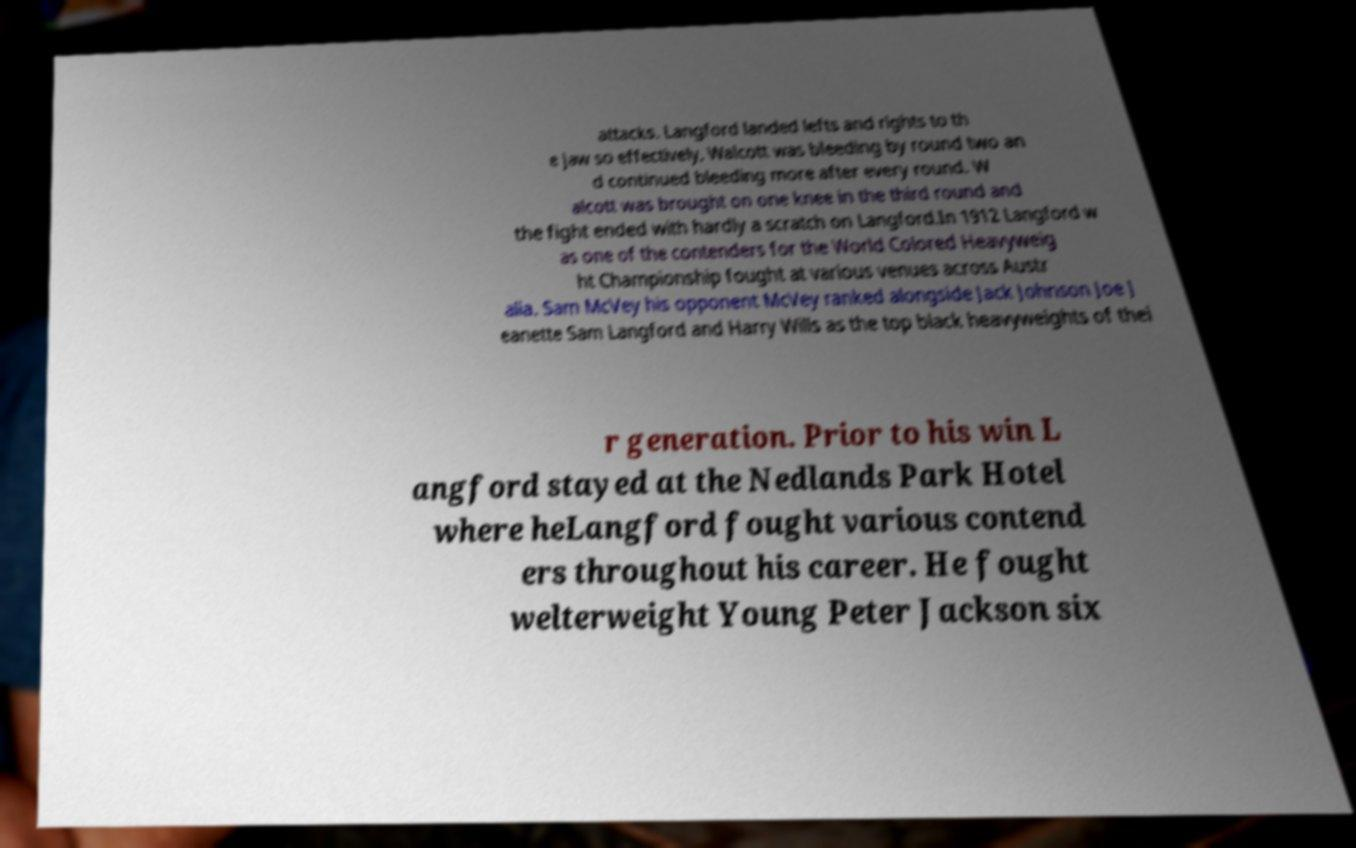Please identify and transcribe the text found in this image. attacks. Langford landed lefts and rights to th e jaw so effectively, Walcott was bleeding by round two an d continued bleeding more after every round. W alcott was brought on one knee in the third round and the fight ended with hardly a scratch on Langford.In 1912 Langford w as one of the contenders for the World Colored Heavyweig ht Championship fought at various venues across Austr alia. Sam McVey his opponent McVey ranked alongside Jack Johnson Joe J eanette Sam Langford and Harry Wills as the top black heavyweights of thei r generation. Prior to his win L angford stayed at the Nedlands Park Hotel where heLangford fought various contend ers throughout his career. He fought welterweight Young Peter Jackson six 